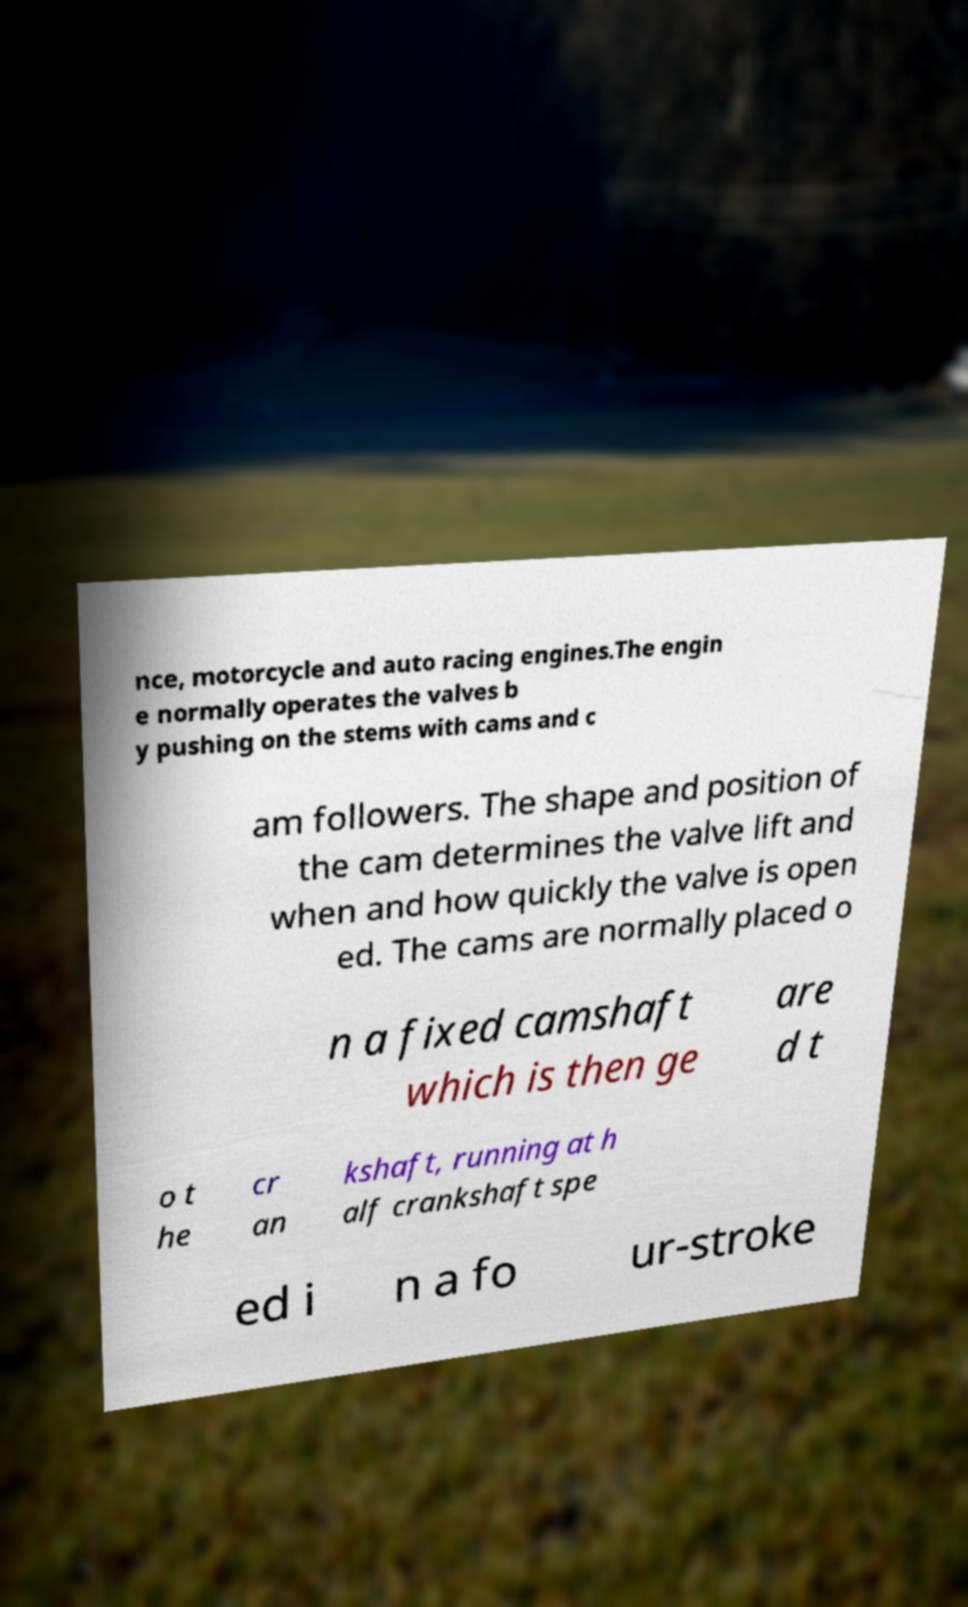Could you extract and type out the text from this image? nce, motorcycle and auto racing engines.The engin e normally operates the valves b y pushing on the stems with cams and c am followers. The shape and position of the cam determines the valve lift and when and how quickly the valve is open ed. The cams are normally placed o n a fixed camshaft which is then ge are d t o t he cr an kshaft, running at h alf crankshaft spe ed i n a fo ur-stroke 